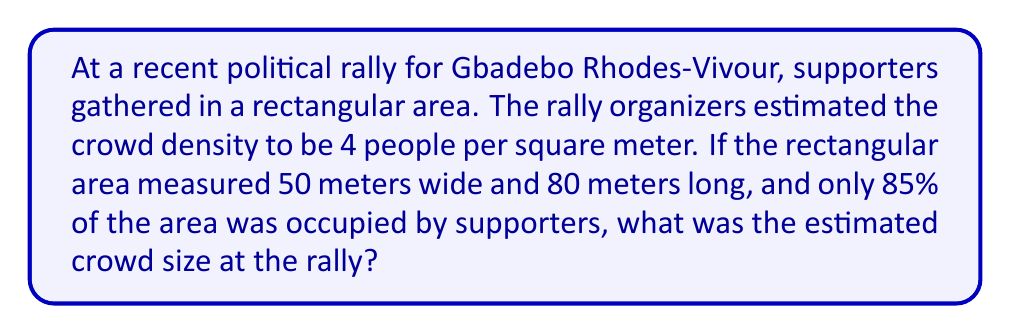Give your solution to this math problem. To solve this problem, we'll follow these steps:

1. Calculate the total area of the rectangular rally space:
   $$A_{total} = \text{width} \times \text{length}$$
   $$A_{total} = 50 \text{ m} \times 80 \text{ m} = 4000 \text{ m}^2$$

2. Determine the occupied area (85% of the total):
   $$A_{occupied} = 0.85 \times A_{total}$$
   $$A_{occupied} = 0.85 \times 4000 \text{ m}^2 = 3400 \text{ m}^2$$

3. Calculate the crowd size using the given density:
   $$\text{Crowd size} = \text{Density} \times A_{occupied}$$
   $$\text{Crowd size} = 4 \text{ people/m}^2 \times 3400 \text{ m}^2 = 13600 \text{ people}$$

Therefore, the estimated crowd size at Gbadebo Rhodes-Vivour's rally was 13,600 people.
Answer: 13,600 people 